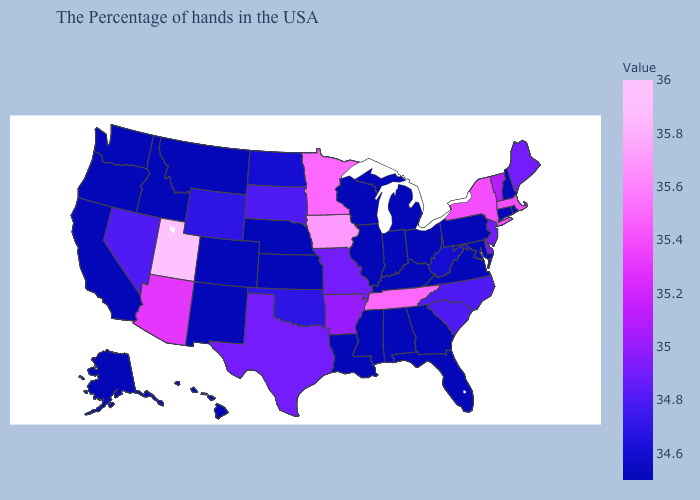Among the states that border Maryland , does Delaware have the highest value?
Keep it brief. Yes. Among the states that border Alabama , which have the highest value?
Quick response, please. Tennessee. Does Missouri have the lowest value in the MidWest?
Keep it brief. No. Does Connecticut have the lowest value in the USA?
Be succinct. Yes. 